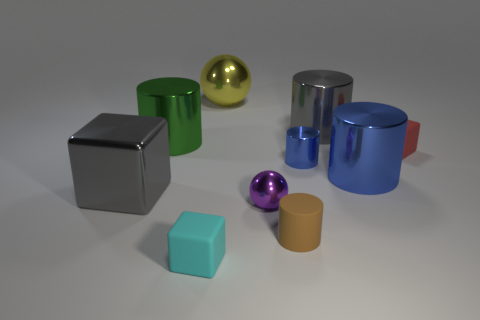There is a small matte thing that is left of the large metallic thing behind the gray metallic thing that is on the right side of the gray cube; what shape is it?
Give a very brief answer. Cube. Are there the same number of big yellow shiny objects behind the big blue object and tiny brown objects?
Offer a very short reply. Yes. Is the size of the purple object the same as the cyan thing?
Your response must be concise. Yes. What number of shiny things are big things or small brown cylinders?
Provide a succinct answer. 5. What is the material of the block that is the same size as the yellow metal thing?
Your answer should be very brief. Metal. How many other objects are the same material as the large blue cylinder?
Offer a very short reply. 6. Is the number of large gray shiny cylinders right of the red cube less than the number of large brown objects?
Give a very brief answer. No. Does the tiny brown thing have the same shape as the big green object?
Give a very brief answer. Yes. How big is the gray metal thing behind the gray metal thing that is on the left side of the matte cube that is in front of the red thing?
Your answer should be compact. Large. There is a tiny blue object that is the same shape as the small brown object; what is it made of?
Offer a very short reply. Metal. 